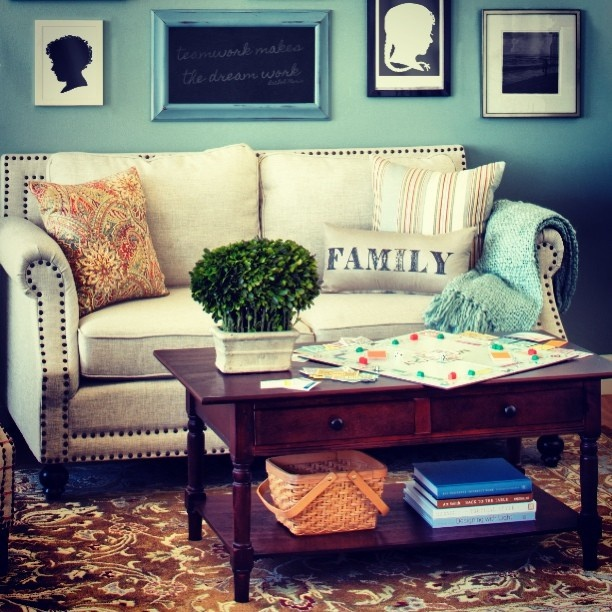Describe the objects in this image and their specific colors. I can see couch in teal, beige, darkgray, and gray tones, potted plant in teal, black, beige, and darkgreen tones, book in teal, navy, blue, and gray tones, vase in teal, beige, and tan tones, and book in teal, beige, lightblue, darkgray, and gray tones in this image. 